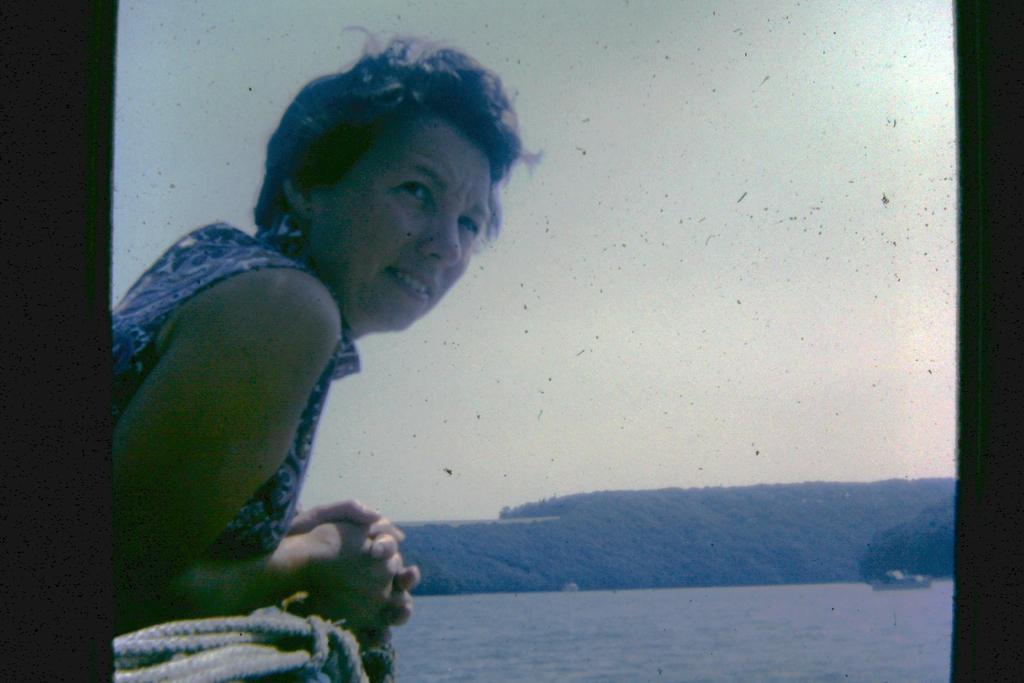How would you summarize this image in a sentence or two? In this picture I can observe a woman on the left side. There is a rope beside her. In front of her there is a river. In the background I can observe trees and a sky. 